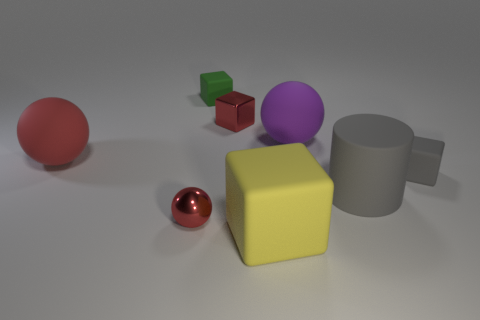Subtract all big yellow cubes. How many cubes are left? 3 Subtract all yellow blocks. How many blocks are left? 3 Subtract all balls. How many objects are left? 5 Subtract 1 cylinders. How many cylinders are left? 0 Add 1 small gray blocks. How many objects exist? 9 Add 6 big purple balls. How many big purple balls exist? 7 Subtract 0 blue cylinders. How many objects are left? 8 Subtract all brown cubes. Subtract all blue spheres. How many cubes are left? 4 Subtract all yellow cylinders. How many gray cubes are left? 1 Subtract all big things. Subtract all small metallic balls. How many objects are left? 3 